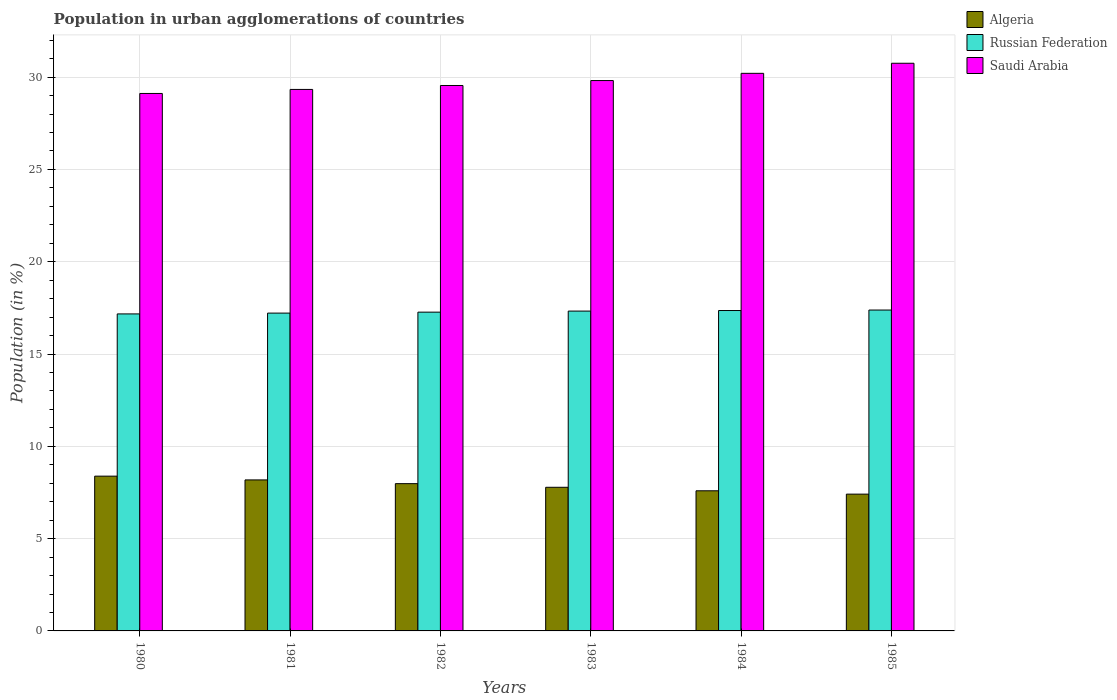How many different coloured bars are there?
Ensure brevity in your answer.  3. Are the number of bars on each tick of the X-axis equal?
Provide a succinct answer. Yes. How many bars are there on the 4th tick from the left?
Your answer should be compact. 3. How many bars are there on the 5th tick from the right?
Your answer should be compact. 3. What is the percentage of population in urban agglomerations in Saudi Arabia in 1982?
Your answer should be very brief. 29.55. Across all years, what is the maximum percentage of population in urban agglomerations in Russian Federation?
Keep it short and to the point. 17.38. Across all years, what is the minimum percentage of population in urban agglomerations in Saudi Arabia?
Offer a very short reply. 29.12. In which year was the percentage of population in urban agglomerations in Algeria maximum?
Ensure brevity in your answer.  1980. What is the total percentage of population in urban agglomerations in Russian Federation in the graph?
Offer a very short reply. 103.73. What is the difference between the percentage of population in urban agglomerations in Russian Federation in 1981 and that in 1985?
Your answer should be very brief. -0.17. What is the difference between the percentage of population in urban agglomerations in Algeria in 1981 and the percentage of population in urban agglomerations in Saudi Arabia in 1984?
Offer a very short reply. -22.03. What is the average percentage of population in urban agglomerations in Saudi Arabia per year?
Provide a succinct answer. 29.8. In the year 1980, what is the difference between the percentage of population in urban agglomerations in Russian Federation and percentage of population in urban agglomerations in Saudi Arabia?
Provide a succinct answer. -11.94. In how many years, is the percentage of population in urban agglomerations in Saudi Arabia greater than 4 %?
Provide a succinct answer. 6. What is the ratio of the percentage of population in urban agglomerations in Russian Federation in 1981 to that in 1984?
Make the answer very short. 0.99. Is the difference between the percentage of population in urban agglomerations in Russian Federation in 1982 and 1985 greater than the difference between the percentage of population in urban agglomerations in Saudi Arabia in 1982 and 1985?
Your answer should be compact. Yes. What is the difference between the highest and the second highest percentage of population in urban agglomerations in Algeria?
Make the answer very short. 0.2. What is the difference between the highest and the lowest percentage of population in urban agglomerations in Russian Federation?
Ensure brevity in your answer.  0.21. In how many years, is the percentage of population in urban agglomerations in Algeria greater than the average percentage of population in urban agglomerations in Algeria taken over all years?
Your answer should be compact. 3. Is the sum of the percentage of population in urban agglomerations in Algeria in 1980 and 1982 greater than the maximum percentage of population in urban agglomerations in Russian Federation across all years?
Ensure brevity in your answer.  No. What does the 2nd bar from the left in 1985 represents?
Give a very brief answer. Russian Federation. What does the 3rd bar from the right in 1982 represents?
Your answer should be compact. Algeria. Are the values on the major ticks of Y-axis written in scientific E-notation?
Your answer should be compact. No. Where does the legend appear in the graph?
Give a very brief answer. Top right. How are the legend labels stacked?
Provide a succinct answer. Vertical. What is the title of the graph?
Ensure brevity in your answer.  Population in urban agglomerations of countries. What is the label or title of the Y-axis?
Offer a very short reply. Population (in %). What is the Population (in %) in Algeria in 1980?
Give a very brief answer. 8.38. What is the Population (in %) in Russian Federation in 1980?
Offer a very short reply. 17.17. What is the Population (in %) in Saudi Arabia in 1980?
Your answer should be very brief. 29.12. What is the Population (in %) of Algeria in 1981?
Your response must be concise. 8.18. What is the Population (in %) in Russian Federation in 1981?
Give a very brief answer. 17.22. What is the Population (in %) in Saudi Arabia in 1981?
Your answer should be compact. 29.34. What is the Population (in %) of Algeria in 1982?
Keep it short and to the point. 7.98. What is the Population (in %) of Russian Federation in 1982?
Ensure brevity in your answer.  17.27. What is the Population (in %) of Saudi Arabia in 1982?
Your response must be concise. 29.55. What is the Population (in %) in Algeria in 1983?
Your answer should be very brief. 7.78. What is the Population (in %) in Russian Federation in 1983?
Offer a very short reply. 17.33. What is the Population (in %) of Saudi Arabia in 1983?
Provide a succinct answer. 29.82. What is the Population (in %) of Algeria in 1984?
Offer a very short reply. 7.59. What is the Population (in %) of Russian Federation in 1984?
Give a very brief answer. 17.36. What is the Population (in %) in Saudi Arabia in 1984?
Your answer should be compact. 30.21. What is the Population (in %) in Algeria in 1985?
Your answer should be compact. 7.41. What is the Population (in %) of Russian Federation in 1985?
Offer a very short reply. 17.38. What is the Population (in %) of Saudi Arabia in 1985?
Provide a short and direct response. 30.75. Across all years, what is the maximum Population (in %) of Algeria?
Your answer should be compact. 8.38. Across all years, what is the maximum Population (in %) in Russian Federation?
Ensure brevity in your answer.  17.38. Across all years, what is the maximum Population (in %) in Saudi Arabia?
Offer a terse response. 30.75. Across all years, what is the minimum Population (in %) in Algeria?
Offer a terse response. 7.41. Across all years, what is the minimum Population (in %) in Russian Federation?
Your response must be concise. 17.17. Across all years, what is the minimum Population (in %) in Saudi Arabia?
Your answer should be compact. 29.12. What is the total Population (in %) in Algeria in the graph?
Provide a short and direct response. 47.33. What is the total Population (in %) of Russian Federation in the graph?
Give a very brief answer. 103.73. What is the total Population (in %) of Saudi Arabia in the graph?
Offer a terse response. 178.78. What is the difference between the Population (in %) of Algeria in 1980 and that in 1981?
Provide a succinct answer. 0.2. What is the difference between the Population (in %) in Russian Federation in 1980 and that in 1981?
Your answer should be very brief. -0.04. What is the difference between the Population (in %) of Saudi Arabia in 1980 and that in 1981?
Your answer should be very brief. -0.22. What is the difference between the Population (in %) of Algeria in 1980 and that in 1982?
Make the answer very short. 0.41. What is the difference between the Population (in %) in Russian Federation in 1980 and that in 1982?
Give a very brief answer. -0.1. What is the difference between the Population (in %) of Saudi Arabia in 1980 and that in 1982?
Keep it short and to the point. -0.43. What is the difference between the Population (in %) of Algeria in 1980 and that in 1983?
Offer a very short reply. 0.6. What is the difference between the Population (in %) in Russian Federation in 1980 and that in 1983?
Provide a succinct answer. -0.15. What is the difference between the Population (in %) in Saudi Arabia in 1980 and that in 1983?
Keep it short and to the point. -0.7. What is the difference between the Population (in %) in Algeria in 1980 and that in 1984?
Your response must be concise. 0.79. What is the difference between the Population (in %) of Russian Federation in 1980 and that in 1984?
Keep it short and to the point. -0.18. What is the difference between the Population (in %) in Saudi Arabia in 1980 and that in 1984?
Keep it short and to the point. -1.09. What is the difference between the Population (in %) of Russian Federation in 1980 and that in 1985?
Make the answer very short. -0.21. What is the difference between the Population (in %) in Saudi Arabia in 1980 and that in 1985?
Provide a succinct answer. -1.64. What is the difference between the Population (in %) of Algeria in 1981 and that in 1982?
Your answer should be compact. 0.2. What is the difference between the Population (in %) in Russian Federation in 1981 and that in 1982?
Your answer should be very brief. -0.05. What is the difference between the Population (in %) in Saudi Arabia in 1981 and that in 1982?
Provide a short and direct response. -0.21. What is the difference between the Population (in %) of Algeria in 1981 and that in 1983?
Provide a short and direct response. 0.4. What is the difference between the Population (in %) of Russian Federation in 1981 and that in 1983?
Offer a very short reply. -0.11. What is the difference between the Population (in %) of Saudi Arabia in 1981 and that in 1983?
Give a very brief answer. -0.48. What is the difference between the Population (in %) of Algeria in 1981 and that in 1984?
Make the answer very short. 0.59. What is the difference between the Population (in %) in Russian Federation in 1981 and that in 1984?
Your response must be concise. -0.14. What is the difference between the Population (in %) in Saudi Arabia in 1981 and that in 1984?
Provide a succinct answer. -0.87. What is the difference between the Population (in %) of Algeria in 1981 and that in 1985?
Offer a very short reply. 0.77. What is the difference between the Population (in %) of Russian Federation in 1981 and that in 1985?
Ensure brevity in your answer.  -0.17. What is the difference between the Population (in %) of Saudi Arabia in 1981 and that in 1985?
Your response must be concise. -1.42. What is the difference between the Population (in %) of Algeria in 1982 and that in 1983?
Ensure brevity in your answer.  0.2. What is the difference between the Population (in %) of Russian Federation in 1982 and that in 1983?
Your response must be concise. -0.06. What is the difference between the Population (in %) in Saudi Arabia in 1982 and that in 1983?
Provide a short and direct response. -0.27. What is the difference between the Population (in %) of Algeria in 1982 and that in 1984?
Ensure brevity in your answer.  0.39. What is the difference between the Population (in %) in Russian Federation in 1982 and that in 1984?
Ensure brevity in your answer.  -0.09. What is the difference between the Population (in %) in Saudi Arabia in 1982 and that in 1984?
Give a very brief answer. -0.66. What is the difference between the Population (in %) of Algeria in 1982 and that in 1985?
Provide a succinct answer. 0.57. What is the difference between the Population (in %) in Russian Federation in 1982 and that in 1985?
Provide a succinct answer. -0.11. What is the difference between the Population (in %) in Saudi Arabia in 1982 and that in 1985?
Offer a terse response. -1.2. What is the difference between the Population (in %) of Algeria in 1983 and that in 1984?
Your answer should be very brief. 0.19. What is the difference between the Population (in %) in Russian Federation in 1983 and that in 1984?
Your answer should be compact. -0.03. What is the difference between the Population (in %) of Saudi Arabia in 1983 and that in 1984?
Provide a succinct answer. -0.39. What is the difference between the Population (in %) in Algeria in 1983 and that in 1985?
Your answer should be very brief. 0.37. What is the difference between the Population (in %) of Russian Federation in 1983 and that in 1985?
Provide a short and direct response. -0.06. What is the difference between the Population (in %) of Saudi Arabia in 1983 and that in 1985?
Your answer should be very brief. -0.94. What is the difference between the Population (in %) of Algeria in 1984 and that in 1985?
Your answer should be compact. 0.18. What is the difference between the Population (in %) in Russian Federation in 1984 and that in 1985?
Ensure brevity in your answer.  -0.03. What is the difference between the Population (in %) of Saudi Arabia in 1984 and that in 1985?
Your answer should be compact. -0.55. What is the difference between the Population (in %) of Algeria in 1980 and the Population (in %) of Russian Federation in 1981?
Your answer should be very brief. -8.83. What is the difference between the Population (in %) of Algeria in 1980 and the Population (in %) of Saudi Arabia in 1981?
Provide a succinct answer. -20.95. What is the difference between the Population (in %) of Russian Federation in 1980 and the Population (in %) of Saudi Arabia in 1981?
Your answer should be compact. -12.16. What is the difference between the Population (in %) of Algeria in 1980 and the Population (in %) of Russian Federation in 1982?
Keep it short and to the point. -8.89. What is the difference between the Population (in %) of Algeria in 1980 and the Population (in %) of Saudi Arabia in 1982?
Provide a short and direct response. -21.16. What is the difference between the Population (in %) in Russian Federation in 1980 and the Population (in %) in Saudi Arabia in 1982?
Offer a very short reply. -12.37. What is the difference between the Population (in %) in Algeria in 1980 and the Population (in %) in Russian Federation in 1983?
Make the answer very short. -8.94. What is the difference between the Population (in %) of Algeria in 1980 and the Population (in %) of Saudi Arabia in 1983?
Your answer should be very brief. -21.43. What is the difference between the Population (in %) of Russian Federation in 1980 and the Population (in %) of Saudi Arabia in 1983?
Your response must be concise. -12.64. What is the difference between the Population (in %) of Algeria in 1980 and the Population (in %) of Russian Federation in 1984?
Give a very brief answer. -8.97. What is the difference between the Population (in %) of Algeria in 1980 and the Population (in %) of Saudi Arabia in 1984?
Your answer should be very brief. -21.82. What is the difference between the Population (in %) in Russian Federation in 1980 and the Population (in %) in Saudi Arabia in 1984?
Your answer should be very brief. -13.03. What is the difference between the Population (in %) in Algeria in 1980 and the Population (in %) in Russian Federation in 1985?
Provide a short and direct response. -9. What is the difference between the Population (in %) in Algeria in 1980 and the Population (in %) in Saudi Arabia in 1985?
Offer a terse response. -22.37. What is the difference between the Population (in %) of Russian Federation in 1980 and the Population (in %) of Saudi Arabia in 1985?
Offer a terse response. -13.58. What is the difference between the Population (in %) in Algeria in 1981 and the Population (in %) in Russian Federation in 1982?
Provide a short and direct response. -9.09. What is the difference between the Population (in %) in Algeria in 1981 and the Population (in %) in Saudi Arabia in 1982?
Your answer should be compact. -21.37. What is the difference between the Population (in %) in Russian Federation in 1981 and the Population (in %) in Saudi Arabia in 1982?
Keep it short and to the point. -12.33. What is the difference between the Population (in %) of Algeria in 1981 and the Population (in %) of Russian Federation in 1983?
Provide a succinct answer. -9.15. What is the difference between the Population (in %) of Algeria in 1981 and the Population (in %) of Saudi Arabia in 1983?
Offer a terse response. -21.64. What is the difference between the Population (in %) in Russian Federation in 1981 and the Population (in %) in Saudi Arabia in 1983?
Your answer should be compact. -12.6. What is the difference between the Population (in %) of Algeria in 1981 and the Population (in %) of Russian Federation in 1984?
Provide a succinct answer. -9.18. What is the difference between the Population (in %) of Algeria in 1981 and the Population (in %) of Saudi Arabia in 1984?
Provide a short and direct response. -22.03. What is the difference between the Population (in %) in Russian Federation in 1981 and the Population (in %) in Saudi Arabia in 1984?
Give a very brief answer. -12.99. What is the difference between the Population (in %) of Algeria in 1981 and the Population (in %) of Russian Federation in 1985?
Your answer should be compact. -9.2. What is the difference between the Population (in %) in Algeria in 1981 and the Population (in %) in Saudi Arabia in 1985?
Your response must be concise. -22.57. What is the difference between the Population (in %) in Russian Federation in 1981 and the Population (in %) in Saudi Arabia in 1985?
Provide a succinct answer. -13.54. What is the difference between the Population (in %) of Algeria in 1982 and the Population (in %) of Russian Federation in 1983?
Your response must be concise. -9.35. What is the difference between the Population (in %) of Algeria in 1982 and the Population (in %) of Saudi Arabia in 1983?
Make the answer very short. -21.84. What is the difference between the Population (in %) of Russian Federation in 1982 and the Population (in %) of Saudi Arabia in 1983?
Your response must be concise. -12.55. What is the difference between the Population (in %) of Algeria in 1982 and the Population (in %) of Russian Federation in 1984?
Your answer should be compact. -9.38. What is the difference between the Population (in %) in Algeria in 1982 and the Population (in %) in Saudi Arabia in 1984?
Give a very brief answer. -22.23. What is the difference between the Population (in %) of Russian Federation in 1982 and the Population (in %) of Saudi Arabia in 1984?
Provide a succinct answer. -12.94. What is the difference between the Population (in %) in Algeria in 1982 and the Population (in %) in Russian Federation in 1985?
Keep it short and to the point. -9.41. What is the difference between the Population (in %) of Algeria in 1982 and the Population (in %) of Saudi Arabia in 1985?
Ensure brevity in your answer.  -22.77. What is the difference between the Population (in %) in Russian Federation in 1982 and the Population (in %) in Saudi Arabia in 1985?
Make the answer very short. -13.48. What is the difference between the Population (in %) in Algeria in 1983 and the Population (in %) in Russian Federation in 1984?
Your response must be concise. -9.58. What is the difference between the Population (in %) in Algeria in 1983 and the Population (in %) in Saudi Arabia in 1984?
Offer a very short reply. -22.43. What is the difference between the Population (in %) in Russian Federation in 1983 and the Population (in %) in Saudi Arabia in 1984?
Make the answer very short. -12.88. What is the difference between the Population (in %) in Algeria in 1983 and the Population (in %) in Russian Federation in 1985?
Offer a very short reply. -9.6. What is the difference between the Population (in %) of Algeria in 1983 and the Population (in %) of Saudi Arabia in 1985?
Give a very brief answer. -22.97. What is the difference between the Population (in %) of Russian Federation in 1983 and the Population (in %) of Saudi Arabia in 1985?
Make the answer very short. -13.43. What is the difference between the Population (in %) in Algeria in 1984 and the Population (in %) in Russian Federation in 1985?
Your answer should be compact. -9.79. What is the difference between the Population (in %) in Algeria in 1984 and the Population (in %) in Saudi Arabia in 1985?
Your response must be concise. -23.16. What is the difference between the Population (in %) in Russian Federation in 1984 and the Population (in %) in Saudi Arabia in 1985?
Your answer should be compact. -13.4. What is the average Population (in %) in Algeria per year?
Make the answer very short. 7.89. What is the average Population (in %) in Russian Federation per year?
Your response must be concise. 17.29. What is the average Population (in %) of Saudi Arabia per year?
Your response must be concise. 29.8. In the year 1980, what is the difference between the Population (in %) of Algeria and Population (in %) of Russian Federation?
Give a very brief answer. -8.79. In the year 1980, what is the difference between the Population (in %) in Algeria and Population (in %) in Saudi Arabia?
Provide a succinct answer. -20.73. In the year 1980, what is the difference between the Population (in %) of Russian Federation and Population (in %) of Saudi Arabia?
Provide a succinct answer. -11.94. In the year 1981, what is the difference between the Population (in %) of Algeria and Population (in %) of Russian Federation?
Your response must be concise. -9.04. In the year 1981, what is the difference between the Population (in %) of Algeria and Population (in %) of Saudi Arabia?
Your answer should be very brief. -21.15. In the year 1981, what is the difference between the Population (in %) in Russian Federation and Population (in %) in Saudi Arabia?
Keep it short and to the point. -12.12. In the year 1982, what is the difference between the Population (in %) in Algeria and Population (in %) in Russian Federation?
Provide a succinct answer. -9.29. In the year 1982, what is the difference between the Population (in %) of Algeria and Population (in %) of Saudi Arabia?
Ensure brevity in your answer.  -21.57. In the year 1982, what is the difference between the Population (in %) of Russian Federation and Population (in %) of Saudi Arabia?
Ensure brevity in your answer.  -12.28. In the year 1983, what is the difference between the Population (in %) in Algeria and Population (in %) in Russian Federation?
Provide a succinct answer. -9.55. In the year 1983, what is the difference between the Population (in %) of Algeria and Population (in %) of Saudi Arabia?
Your response must be concise. -22.03. In the year 1983, what is the difference between the Population (in %) of Russian Federation and Population (in %) of Saudi Arabia?
Offer a very short reply. -12.49. In the year 1984, what is the difference between the Population (in %) in Algeria and Population (in %) in Russian Federation?
Provide a succinct answer. -9.77. In the year 1984, what is the difference between the Population (in %) in Algeria and Population (in %) in Saudi Arabia?
Ensure brevity in your answer.  -22.62. In the year 1984, what is the difference between the Population (in %) of Russian Federation and Population (in %) of Saudi Arabia?
Ensure brevity in your answer.  -12.85. In the year 1985, what is the difference between the Population (in %) in Algeria and Population (in %) in Russian Federation?
Offer a terse response. -9.97. In the year 1985, what is the difference between the Population (in %) of Algeria and Population (in %) of Saudi Arabia?
Make the answer very short. -23.34. In the year 1985, what is the difference between the Population (in %) in Russian Federation and Population (in %) in Saudi Arabia?
Provide a succinct answer. -13.37. What is the ratio of the Population (in %) of Algeria in 1980 to that in 1982?
Give a very brief answer. 1.05. What is the ratio of the Population (in %) in Saudi Arabia in 1980 to that in 1982?
Offer a very short reply. 0.99. What is the ratio of the Population (in %) in Algeria in 1980 to that in 1983?
Keep it short and to the point. 1.08. What is the ratio of the Population (in %) in Russian Federation in 1980 to that in 1983?
Provide a succinct answer. 0.99. What is the ratio of the Population (in %) of Saudi Arabia in 1980 to that in 1983?
Ensure brevity in your answer.  0.98. What is the ratio of the Population (in %) of Algeria in 1980 to that in 1984?
Provide a succinct answer. 1.1. What is the ratio of the Population (in %) of Saudi Arabia in 1980 to that in 1984?
Give a very brief answer. 0.96. What is the ratio of the Population (in %) in Algeria in 1980 to that in 1985?
Offer a very short reply. 1.13. What is the ratio of the Population (in %) in Russian Federation in 1980 to that in 1985?
Ensure brevity in your answer.  0.99. What is the ratio of the Population (in %) of Saudi Arabia in 1980 to that in 1985?
Your response must be concise. 0.95. What is the ratio of the Population (in %) of Algeria in 1981 to that in 1982?
Make the answer very short. 1.03. What is the ratio of the Population (in %) in Russian Federation in 1981 to that in 1982?
Your answer should be very brief. 1. What is the ratio of the Population (in %) of Algeria in 1981 to that in 1983?
Make the answer very short. 1.05. What is the ratio of the Population (in %) of Russian Federation in 1981 to that in 1983?
Give a very brief answer. 0.99. What is the ratio of the Population (in %) in Saudi Arabia in 1981 to that in 1983?
Ensure brevity in your answer.  0.98. What is the ratio of the Population (in %) in Algeria in 1981 to that in 1984?
Give a very brief answer. 1.08. What is the ratio of the Population (in %) in Russian Federation in 1981 to that in 1984?
Offer a very short reply. 0.99. What is the ratio of the Population (in %) in Saudi Arabia in 1981 to that in 1984?
Your answer should be very brief. 0.97. What is the ratio of the Population (in %) in Algeria in 1981 to that in 1985?
Provide a succinct answer. 1.1. What is the ratio of the Population (in %) of Russian Federation in 1981 to that in 1985?
Provide a succinct answer. 0.99. What is the ratio of the Population (in %) of Saudi Arabia in 1981 to that in 1985?
Keep it short and to the point. 0.95. What is the ratio of the Population (in %) in Algeria in 1982 to that in 1983?
Ensure brevity in your answer.  1.03. What is the ratio of the Population (in %) in Russian Federation in 1982 to that in 1983?
Provide a short and direct response. 1. What is the ratio of the Population (in %) in Algeria in 1982 to that in 1984?
Your answer should be very brief. 1.05. What is the ratio of the Population (in %) of Russian Federation in 1982 to that in 1984?
Offer a very short reply. 0.99. What is the ratio of the Population (in %) of Saudi Arabia in 1982 to that in 1984?
Your answer should be very brief. 0.98. What is the ratio of the Population (in %) in Algeria in 1982 to that in 1985?
Your answer should be compact. 1.08. What is the ratio of the Population (in %) of Russian Federation in 1982 to that in 1985?
Keep it short and to the point. 0.99. What is the ratio of the Population (in %) of Saudi Arabia in 1982 to that in 1985?
Provide a short and direct response. 0.96. What is the ratio of the Population (in %) of Saudi Arabia in 1983 to that in 1984?
Your response must be concise. 0.99. What is the ratio of the Population (in %) in Algeria in 1983 to that in 1985?
Provide a succinct answer. 1.05. What is the ratio of the Population (in %) in Russian Federation in 1983 to that in 1985?
Make the answer very short. 1. What is the ratio of the Population (in %) in Saudi Arabia in 1983 to that in 1985?
Offer a terse response. 0.97. What is the ratio of the Population (in %) in Algeria in 1984 to that in 1985?
Offer a terse response. 1.02. What is the ratio of the Population (in %) in Saudi Arabia in 1984 to that in 1985?
Offer a terse response. 0.98. What is the difference between the highest and the second highest Population (in %) of Algeria?
Your response must be concise. 0.2. What is the difference between the highest and the second highest Population (in %) of Russian Federation?
Give a very brief answer. 0.03. What is the difference between the highest and the second highest Population (in %) of Saudi Arabia?
Make the answer very short. 0.55. What is the difference between the highest and the lowest Population (in %) in Algeria?
Ensure brevity in your answer.  0.97. What is the difference between the highest and the lowest Population (in %) in Russian Federation?
Offer a very short reply. 0.21. What is the difference between the highest and the lowest Population (in %) in Saudi Arabia?
Provide a short and direct response. 1.64. 